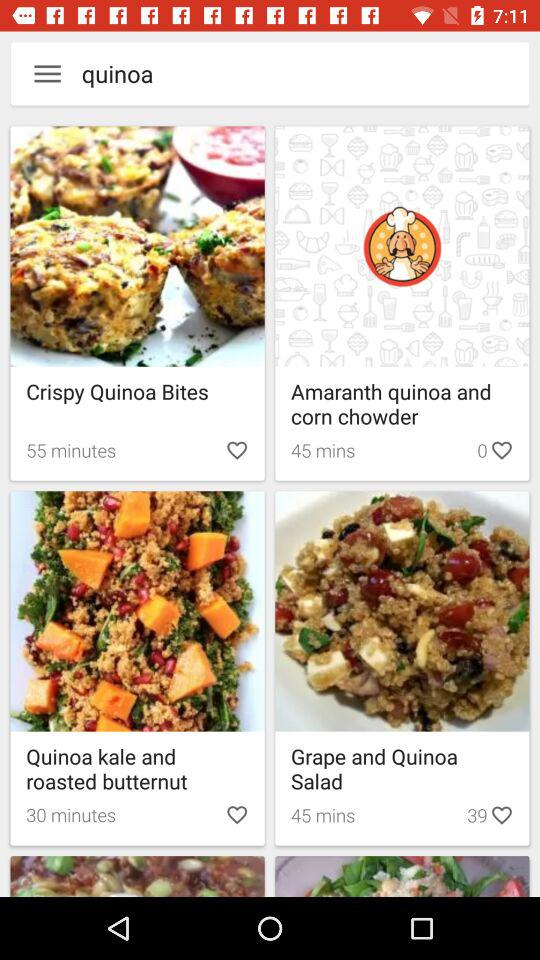How many likes are there for "Grape and Quinoa Salad"? There are 39 likes for "Grape and Quinoa Salad". 